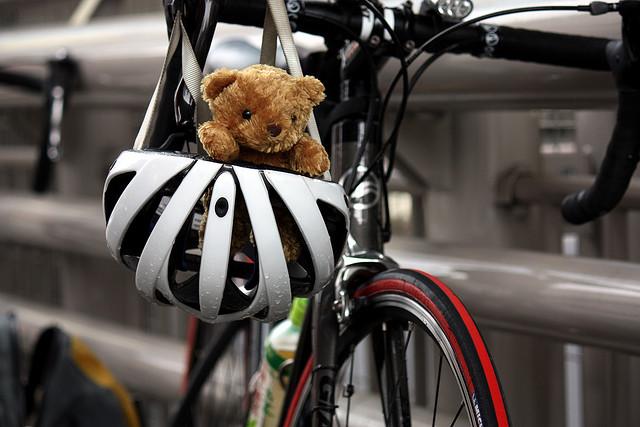What is the bicycle leaning on?
Answer briefly. Rail. What color is the tire?
Give a very brief answer. Red and black. What is in the helmet?
Keep it brief. Teddy bear. 